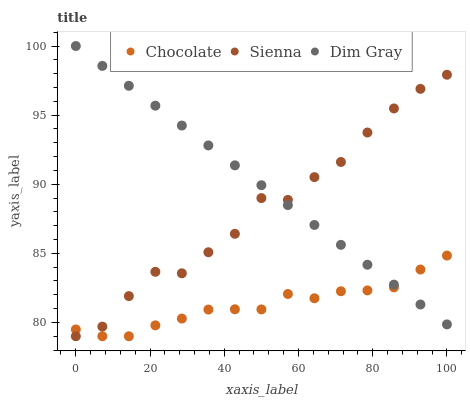Does Chocolate have the minimum area under the curve?
Answer yes or no. Yes. Does Dim Gray have the maximum area under the curve?
Answer yes or no. Yes. Does Dim Gray have the minimum area under the curve?
Answer yes or no. No. Does Chocolate have the maximum area under the curve?
Answer yes or no. No. Is Dim Gray the smoothest?
Answer yes or no. Yes. Is Sienna the roughest?
Answer yes or no. Yes. Is Chocolate the smoothest?
Answer yes or no. No. Is Chocolate the roughest?
Answer yes or no. No. Does Sienna have the lowest value?
Answer yes or no. Yes. Does Dim Gray have the lowest value?
Answer yes or no. No. Does Dim Gray have the highest value?
Answer yes or no. Yes. Does Chocolate have the highest value?
Answer yes or no. No. Does Chocolate intersect Dim Gray?
Answer yes or no. Yes. Is Chocolate less than Dim Gray?
Answer yes or no. No. Is Chocolate greater than Dim Gray?
Answer yes or no. No. 